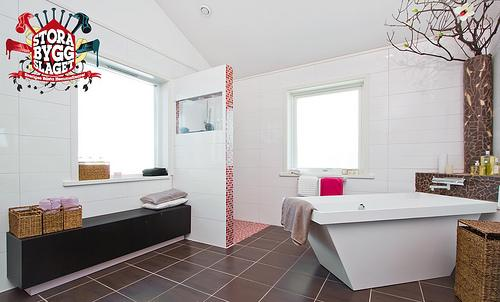How many wicket baskets are on top of the little bench near the doorway? Please explain your reasoning. three. Although there are four baskets on that side, one of them is in the windowsill and not on the little bench. 